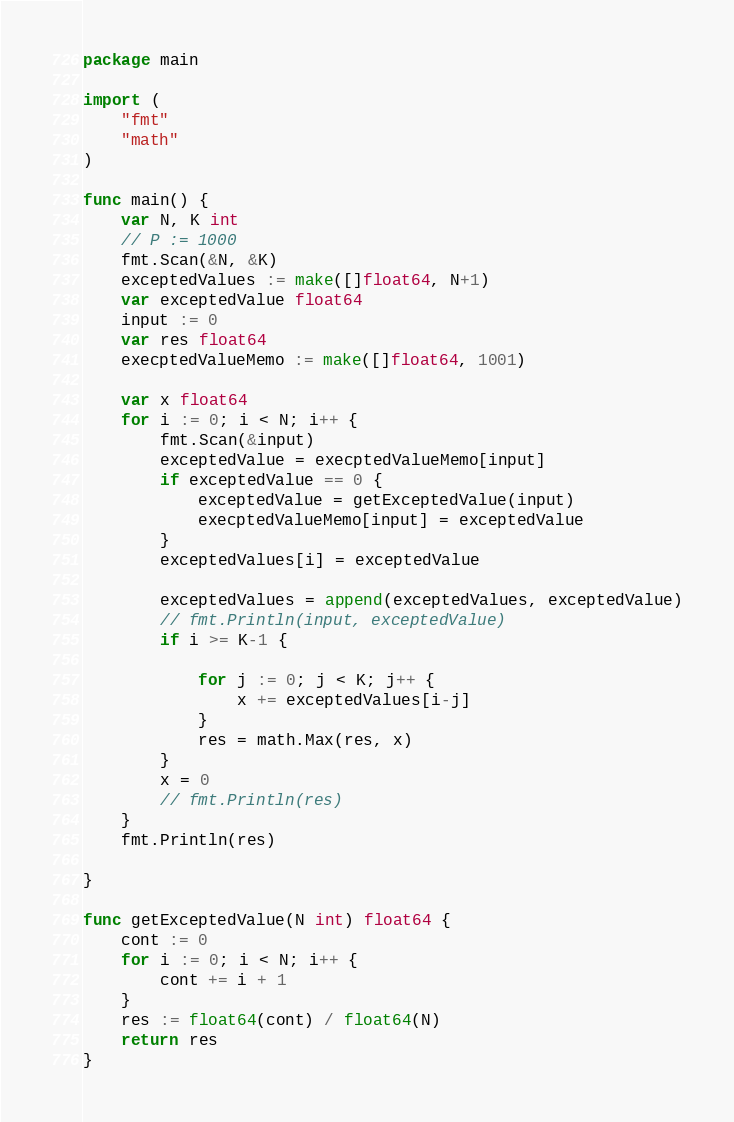Convert code to text. <code><loc_0><loc_0><loc_500><loc_500><_Go_>package main

import (
	"fmt"
	"math"
)

func main() {
	var N, K int
	// P := 1000
	fmt.Scan(&N, &K)
	exceptedValues := make([]float64, N+1)
	var exceptedValue float64
	input := 0
	var res float64
	execptedValueMemo := make([]float64, 1001)

	var x float64
	for i := 0; i < N; i++ {
		fmt.Scan(&input)
		exceptedValue = execptedValueMemo[input]
		if exceptedValue == 0 {
			exceptedValue = getExceptedValue(input)
			execptedValueMemo[input] = exceptedValue
		}
		exceptedValues[i] = exceptedValue

		exceptedValues = append(exceptedValues, exceptedValue)
		// fmt.Println(input, exceptedValue)
		if i >= K-1 {

			for j := 0; j < K; j++ {
				x += exceptedValues[i-j]
			}
			res = math.Max(res, x)
		}
		x = 0
		// fmt.Println(res)
	}
	fmt.Println(res)

}

func getExceptedValue(N int) float64 {
	cont := 0
	for i := 0; i < N; i++ {
		cont += i + 1
	}
	res := float64(cont) / float64(N)
	return res
}
</code> 